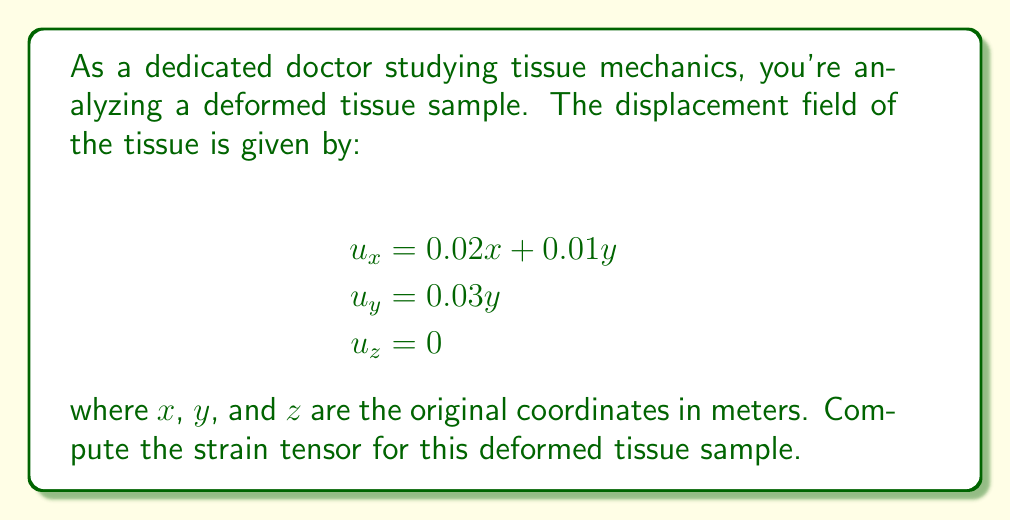What is the answer to this math problem? To compute the strain tensor for the deformed tissue sample, we'll follow these steps:

1) The strain tensor $\varepsilon_{ij}$ is defined as:

   $$\varepsilon_{ij} = \frac{1}{2}\left(\frac{\partial u_i}{\partial x_j} + \frac{\partial u_j}{\partial x_i}\right)$$

2) We need to calculate the partial derivatives:

   $$\frac{\partial u_x}{\partial x} = 0.02$$
   $$\frac{\partial u_x}{\partial y} = 0.01$$
   $$\frac{\partial u_x}{\partial z} = 0$$
   $$\frac{\partial u_y}{\partial x} = 0$$
   $$\frac{\partial u_y}{\partial y} = 0.03$$
   $$\frac{\partial u_y}{\partial z} = 0$$
   $$\frac{\partial u_z}{\partial x} = \frac{\partial u_z}{\partial y} = \frac{\partial u_z}{\partial z} = 0$$

3) Now, we can calculate each component of the strain tensor:

   $$\varepsilon_{xx} = \frac{\partial u_x}{\partial x} = 0.02$$
   
   $$\varepsilon_{yy} = \frac{\partial u_y}{\partial y} = 0.03$$
   
   $$\varepsilon_{zz} = \frac{\partial u_z}{\partial z} = 0$$
   
   $$\varepsilon_{xy} = \varepsilon_{yx} = \frac{1}{2}\left(\frac{\partial u_x}{\partial y} + \frac{\partial u_y}{\partial x}\right) = \frac{1}{2}(0.01 + 0) = 0.005$$
   
   $$\varepsilon_{xz} = \varepsilon_{zx} = \frac{1}{2}\left(\frac{\partial u_x}{\partial z} + \frac{\partial u_z}{\partial x}\right) = 0$$
   
   $$\varepsilon_{yz} = \varepsilon_{zy} = \frac{1}{2}\left(\frac{\partial u_y}{\partial z} + \frac{\partial u_z}{\partial y}\right) = 0$$

4) The strain tensor can now be written as:

   $$\varepsilon = \begin{bmatrix}
   0.02 & 0.005 & 0 \\
   0.005 & 0.03 & 0 \\
   0 & 0 & 0
   \end{bmatrix}$$
Answer: $$\varepsilon = \begin{bmatrix}
0.02 & 0.005 & 0 \\
0.005 & 0.03 & 0 \\
0 & 0 & 0
\end{bmatrix}$$ 